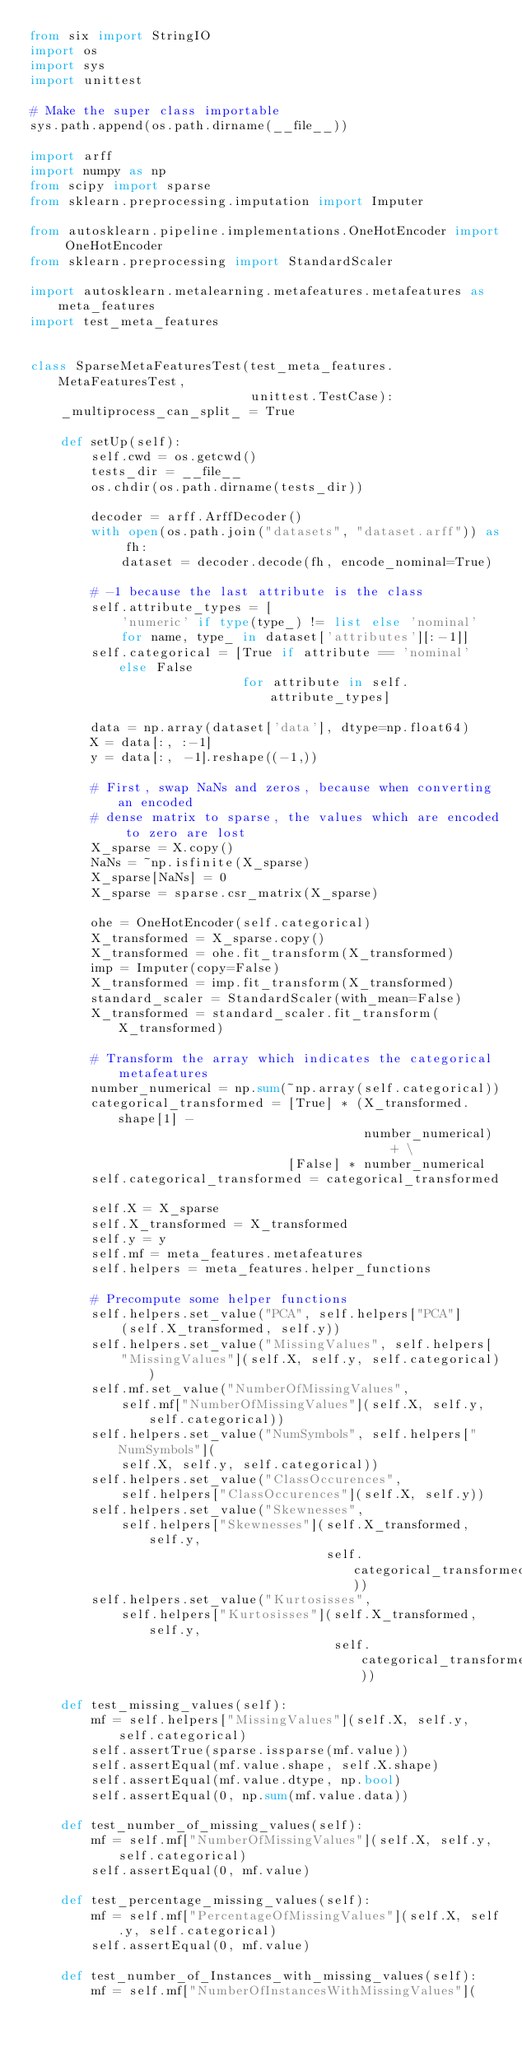<code> <loc_0><loc_0><loc_500><loc_500><_Python_>from six import StringIO
import os
import sys
import unittest

# Make the super class importable
sys.path.append(os.path.dirname(__file__))

import arff
import numpy as np
from scipy import sparse
from sklearn.preprocessing.imputation import Imputer

from autosklearn.pipeline.implementations.OneHotEncoder import OneHotEncoder
from sklearn.preprocessing import StandardScaler

import autosklearn.metalearning.metafeatures.metafeatures as meta_features
import test_meta_features


class SparseMetaFeaturesTest(test_meta_features.MetaFeaturesTest,
                             unittest.TestCase):
    _multiprocess_can_split_ = True

    def setUp(self):
        self.cwd = os.getcwd()
        tests_dir = __file__
        os.chdir(os.path.dirname(tests_dir))

        decoder = arff.ArffDecoder()
        with open(os.path.join("datasets", "dataset.arff")) as fh:
            dataset = decoder.decode(fh, encode_nominal=True)

        # -1 because the last attribute is the class
        self.attribute_types = [
            'numeric' if type(type_) != list else 'nominal'
            for name, type_ in dataset['attributes'][:-1]]
        self.categorical = [True if attribute == 'nominal' else False
                            for attribute in self.attribute_types]

        data = np.array(dataset['data'], dtype=np.float64)
        X = data[:, :-1]
        y = data[:, -1].reshape((-1,))

        # First, swap NaNs and zeros, because when converting an encoded
        # dense matrix to sparse, the values which are encoded to zero are lost
        X_sparse = X.copy()
        NaNs = ~np.isfinite(X_sparse)
        X_sparse[NaNs] = 0
        X_sparse = sparse.csr_matrix(X_sparse)

        ohe = OneHotEncoder(self.categorical)
        X_transformed = X_sparse.copy()
        X_transformed = ohe.fit_transform(X_transformed)
        imp = Imputer(copy=False)
        X_transformed = imp.fit_transform(X_transformed)
        standard_scaler = StandardScaler(with_mean=False)
        X_transformed = standard_scaler.fit_transform(X_transformed)

        # Transform the array which indicates the categorical metafeatures
        number_numerical = np.sum(~np.array(self.categorical))
        categorical_transformed = [True] * (X_transformed.shape[1] -
                                            number_numerical) + \
                                  [False] * number_numerical
        self.categorical_transformed = categorical_transformed

        self.X = X_sparse
        self.X_transformed = X_transformed
        self.y = y
        self.mf = meta_features.metafeatures
        self.helpers = meta_features.helper_functions

        # Precompute some helper functions
        self.helpers.set_value("PCA", self.helpers["PCA"]
            (self.X_transformed, self.y))
        self.helpers.set_value("MissingValues", self.helpers[
            "MissingValues"](self.X, self.y, self.categorical))
        self.mf.set_value("NumberOfMissingValues",
            self.mf["NumberOfMissingValues"](self.X, self.y, self.categorical))
        self.helpers.set_value("NumSymbols", self.helpers["NumSymbols"](
            self.X, self.y, self.categorical))
        self.helpers.set_value("ClassOccurences",
            self.helpers["ClassOccurences"](self.X, self.y))
        self.helpers.set_value("Skewnesses",
            self.helpers["Skewnesses"](self.X_transformed, self.y,
                                       self.categorical_transformed))
        self.helpers.set_value("Kurtosisses",
            self.helpers["Kurtosisses"](self.X_transformed, self.y,
                                        self.categorical_transformed))

    def test_missing_values(self):
        mf = self.helpers["MissingValues"](self.X, self.y, self.categorical)
        self.assertTrue(sparse.issparse(mf.value))
        self.assertEqual(mf.value.shape, self.X.shape)
        self.assertEqual(mf.value.dtype, np.bool)
        self.assertEqual(0, np.sum(mf.value.data))

    def test_number_of_missing_values(self):
        mf = self.mf["NumberOfMissingValues"](self.X, self.y, self.categorical)
        self.assertEqual(0, mf.value)

    def test_percentage_missing_values(self):
        mf = self.mf["PercentageOfMissingValues"](self.X, self.y, self.categorical)
        self.assertEqual(0, mf.value)

    def test_number_of_Instances_with_missing_values(self):
        mf = self.mf["NumberOfInstancesWithMissingValues"](</code> 